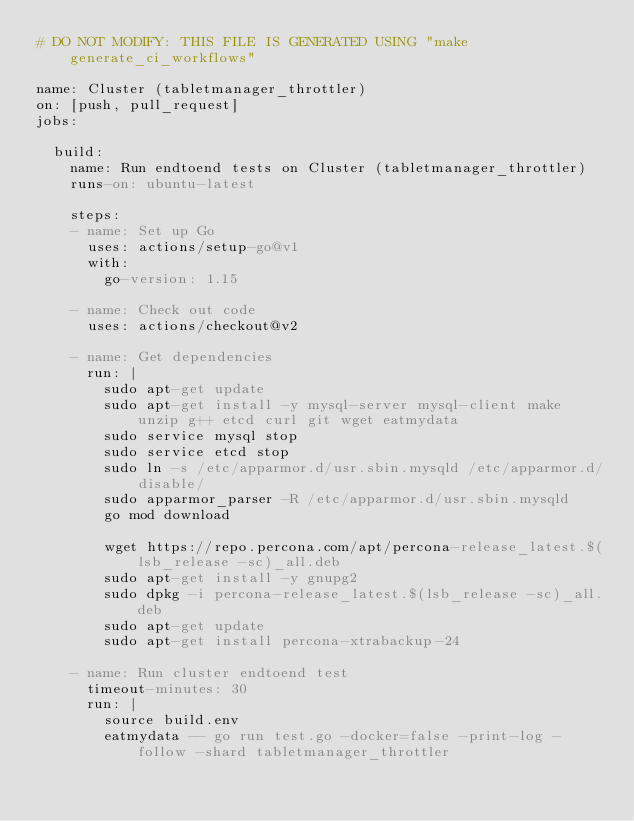<code> <loc_0><loc_0><loc_500><loc_500><_YAML_># DO NOT MODIFY: THIS FILE IS GENERATED USING "make generate_ci_workflows"

name: Cluster (tabletmanager_throttler)
on: [push, pull_request]
jobs:

  build:
    name: Run endtoend tests on Cluster (tabletmanager_throttler)
    runs-on: ubuntu-latest

    steps:
    - name: Set up Go
      uses: actions/setup-go@v1
      with:
        go-version: 1.15

    - name: Check out code
      uses: actions/checkout@v2

    - name: Get dependencies
      run: |
        sudo apt-get update
        sudo apt-get install -y mysql-server mysql-client make unzip g++ etcd curl git wget eatmydata
        sudo service mysql stop
        sudo service etcd stop
        sudo ln -s /etc/apparmor.d/usr.sbin.mysqld /etc/apparmor.d/disable/
        sudo apparmor_parser -R /etc/apparmor.d/usr.sbin.mysqld
        go mod download

        wget https://repo.percona.com/apt/percona-release_latest.$(lsb_release -sc)_all.deb
        sudo apt-get install -y gnupg2
        sudo dpkg -i percona-release_latest.$(lsb_release -sc)_all.deb
        sudo apt-get update
        sudo apt-get install percona-xtrabackup-24

    - name: Run cluster endtoend test
      timeout-minutes: 30
      run: |
        source build.env
        eatmydata -- go run test.go -docker=false -print-log -follow -shard tabletmanager_throttler
</code> 